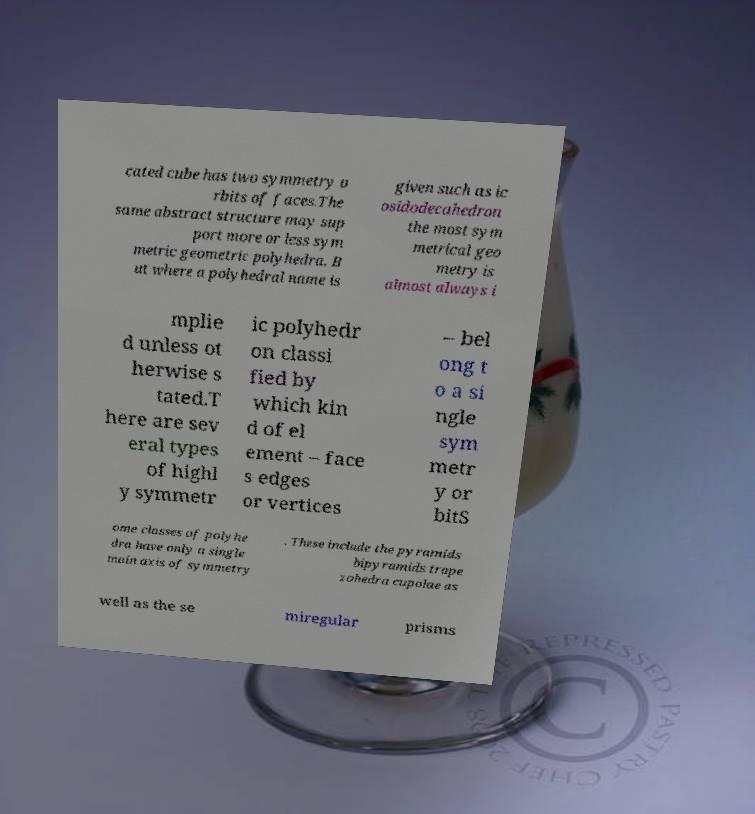For documentation purposes, I need the text within this image transcribed. Could you provide that? cated cube has two symmetry o rbits of faces.The same abstract structure may sup port more or less sym metric geometric polyhedra. B ut where a polyhedral name is given such as ic osidodecahedron the most sym metrical geo metry is almost always i mplie d unless ot herwise s tated.T here are sev eral types of highl y symmetr ic polyhedr on classi fied by which kin d of el ement – face s edges or vertices – bel ong t o a si ngle sym metr y or bitS ome classes of polyhe dra have only a single main axis of symmetry . These include the pyramids bipyramids trape zohedra cupolae as well as the se miregular prisms 